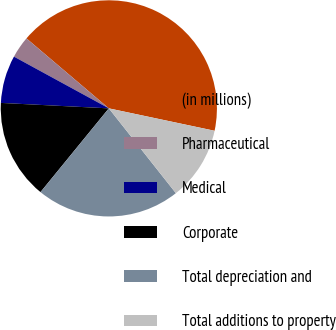Convert chart. <chart><loc_0><loc_0><loc_500><loc_500><pie_chart><fcel>(in millions)<fcel>Pharmaceutical<fcel>Medical<fcel>Corporate<fcel>Total depreciation and<fcel>Total additions to property<nl><fcel>42.12%<fcel>3.26%<fcel>7.14%<fcel>14.91%<fcel>21.54%<fcel>11.03%<nl></chart> 